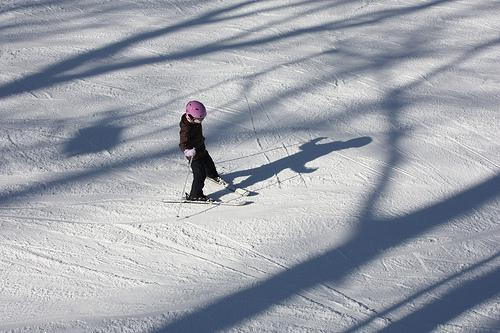Question: what makes the ground white?
Choices:
A. Dust.
B. Cement.
C. Snow.
D. Powder.
Answer with the letter. Answer: C Question: who is wearing the helmet?
Choices:
A. Skateboarder.
B. The child.
C. Skiier.
D. Biker.
Answer with the letter. Answer: B Question: how many skis is the child wearing?
Choices:
A. One.
B. Two.
C. Three.
D. Four.
Answer with the letter. Answer: B Question: what are the shadows coming from?
Choices:
A. Clouds.
B. Circus tent.
C. An elephant.
D. Trees.
Answer with the letter. Answer: D 